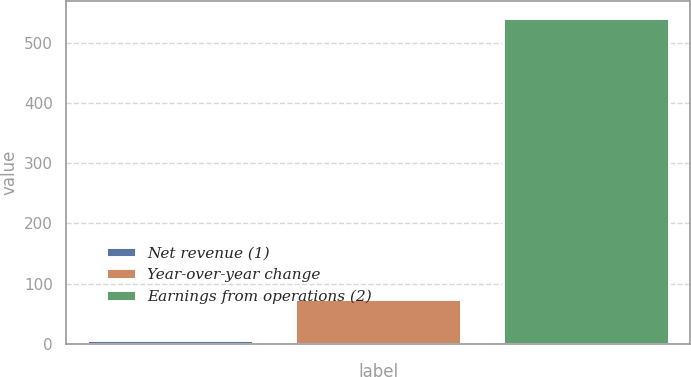<chart> <loc_0><loc_0><loc_500><loc_500><bar_chart><fcel>Net revenue (1)<fcel>Year-over-year change<fcel>Earnings from operations (2)<nl><fcel>7<fcel>75<fcel>542<nl></chart> 